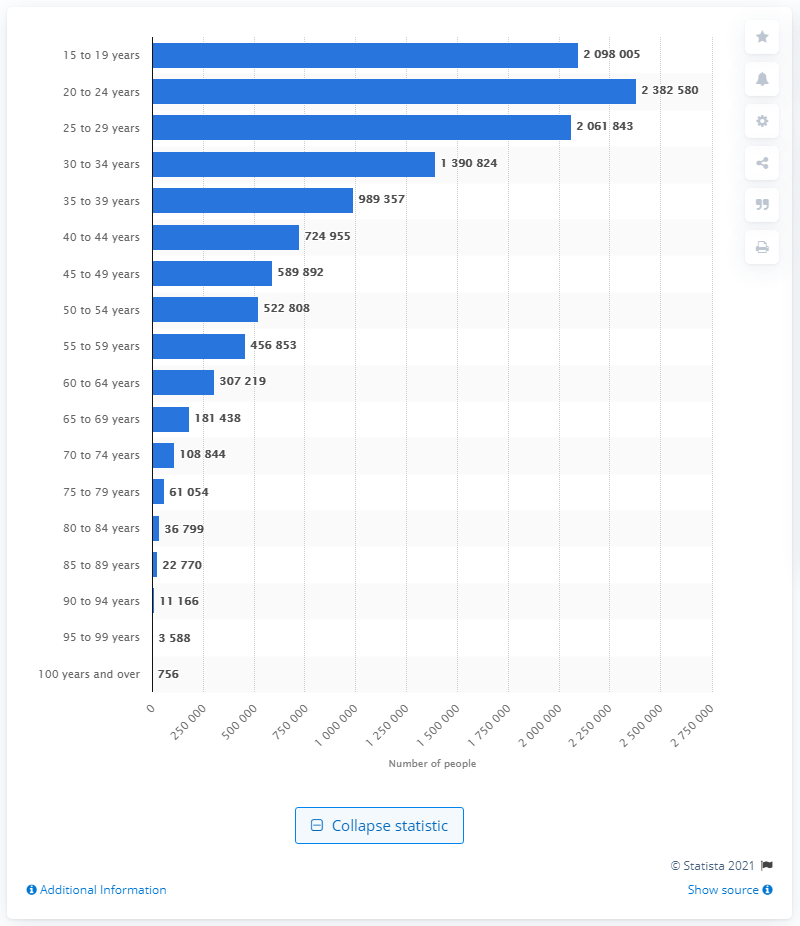Identify some key points in this picture. In 2020, it is estimated that there were approximately 238,2580 single people living in Canada. In 2020, there were 756 single people aged 100 or older living in Canada. 